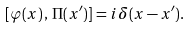<formula> <loc_0><loc_0><loc_500><loc_500>[ \varphi ( x ) \, , \, \Pi ( x ^ { \prime } ) ] = i \, \delta ( x - x ^ { \prime } ) .</formula> 